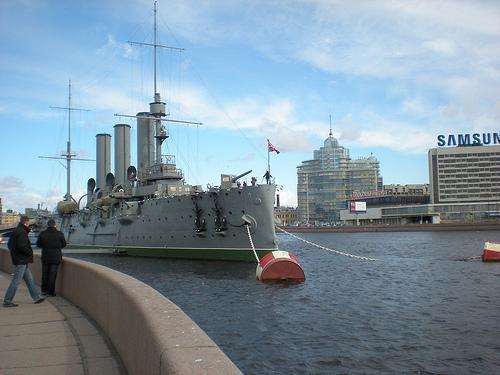How many masts does the ship have?
Give a very brief answer. 2. How many people are watching the boat?
Give a very brief answer. 2. 